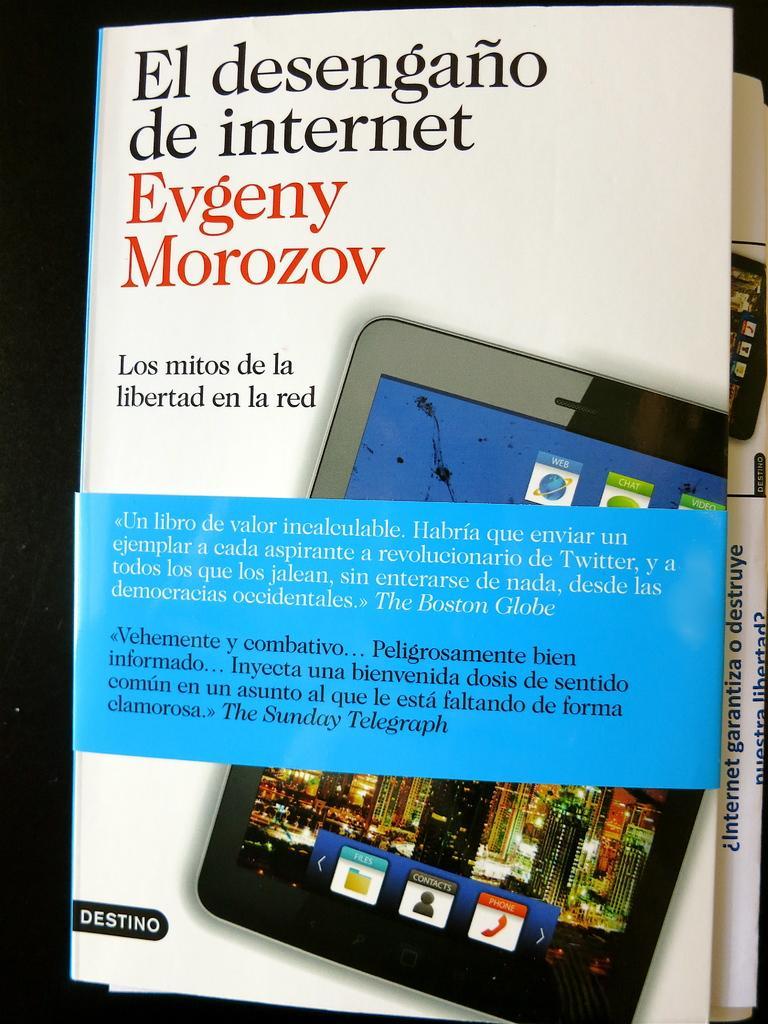How would you summarize this image in a sentence or two? In this image we can see two posts with some text and images, also we can see the background is dark. 